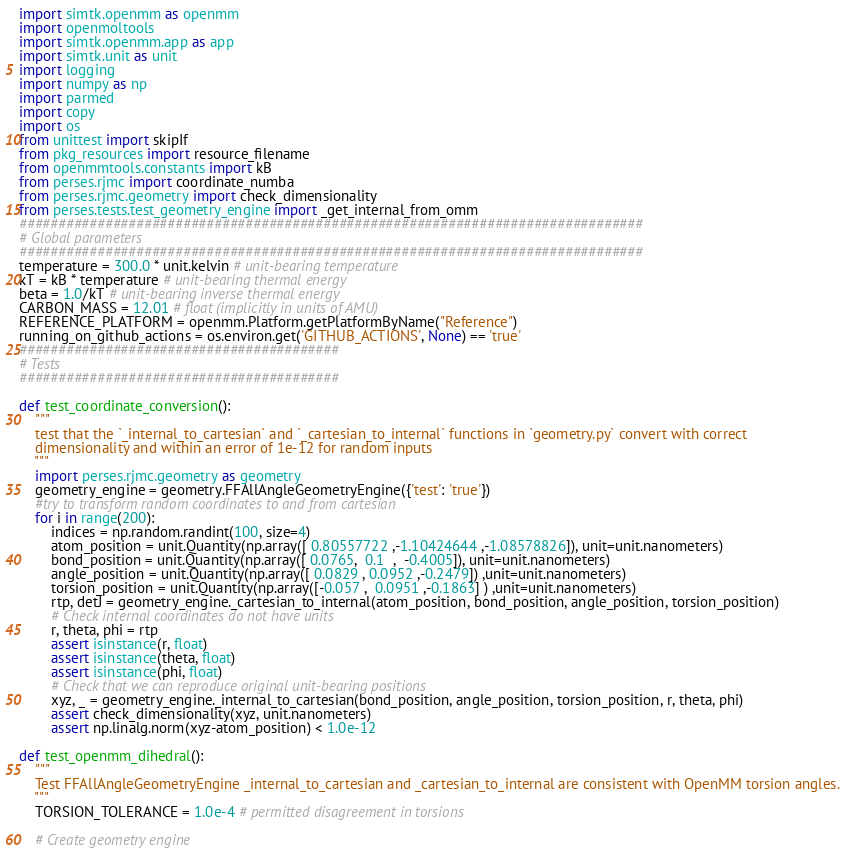<code> <loc_0><loc_0><loc_500><loc_500><_Python_>import simtk.openmm as openmm
import openmoltools
import simtk.openmm.app as app
import simtk.unit as unit
import logging
import numpy as np
import parmed
import copy
import os
from unittest import skipIf
from pkg_resources import resource_filename
from openmmtools.constants import kB
from perses.rjmc import coordinate_numba
from perses.rjmc.geometry import check_dimensionality
from perses.tests.test_geometry_engine import _get_internal_from_omm
################################################################################
# Global parameters
################################################################################
temperature = 300.0 * unit.kelvin # unit-bearing temperature
kT = kB * temperature # unit-bearing thermal energy
beta = 1.0/kT # unit-bearing inverse thermal energy
CARBON_MASS = 12.01 # float (implicitly in units of AMU)
REFERENCE_PLATFORM = openmm.Platform.getPlatformByName("Reference")
running_on_github_actions = os.environ.get('GITHUB_ACTIONS', None) == 'true'
#########################################
# Tests
#########################################

def test_coordinate_conversion():
    """
    test that the `_internal_to_cartesian` and `_cartesian_to_internal` functions in `geometry.py` convert with correct
    dimensionality and within an error of 1e-12 for random inputs
    """
    import perses.rjmc.geometry as geometry
    geometry_engine = geometry.FFAllAngleGeometryEngine({'test': 'true'})
    #try to transform random coordinates to and from cartesian
    for i in range(200):
        indices = np.random.randint(100, size=4)
        atom_position = unit.Quantity(np.array([ 0.80557722 ,-1.10424644 ,-1.08578826]), unit=unit.nanometers)
        bond_position = unit.Quantity(np.array([ 0.0765,  0.1  ,  -0.4005]), unit=unit.nanometers)
        angle_position = unit.Quantity(np.array([ 0.0829 , 0.0952 ,-0.2479]) ,unit=unit.nanometers)
        torsion_position = unit.Quantity(np.array([-0.057 ,  0.0951 ,-0.1863] ) ,unit=unit.nanometers)
        rtp, detJ = geometry_engine._cartesian_to_internal(atom_position, bond_position, angle_position, torsion_position)
        # Check internal coordinates do not have units
        r, theta, phi = rtp
        assert isinstance(r, float)
        assert isinstance(theta, float)
        assert isinstance(phi, float)
        # Check that we can reproduce original unit-bearing positions
        xyz, _ = geometry_engine._internal_to_cartesian(bond_position, angle_position, torsion_position, r, theta, phi)
        assert check_dimensionality(xyz, unit.nanometers)
        assert np.linalg.norm(xyz-atom_position) < 1.0e-12

def test_openmm_dihedral():
    """
    Test FFAllAngleGeometryEngine _internal_to_cartesian and _cartesian_to_internal are consistent with OpenMM torsion angles.
    """
    TORSION_TOLERANCE = 1.0e-4 # permitted disagreement in torsions

    # Create geometry engine</code> 